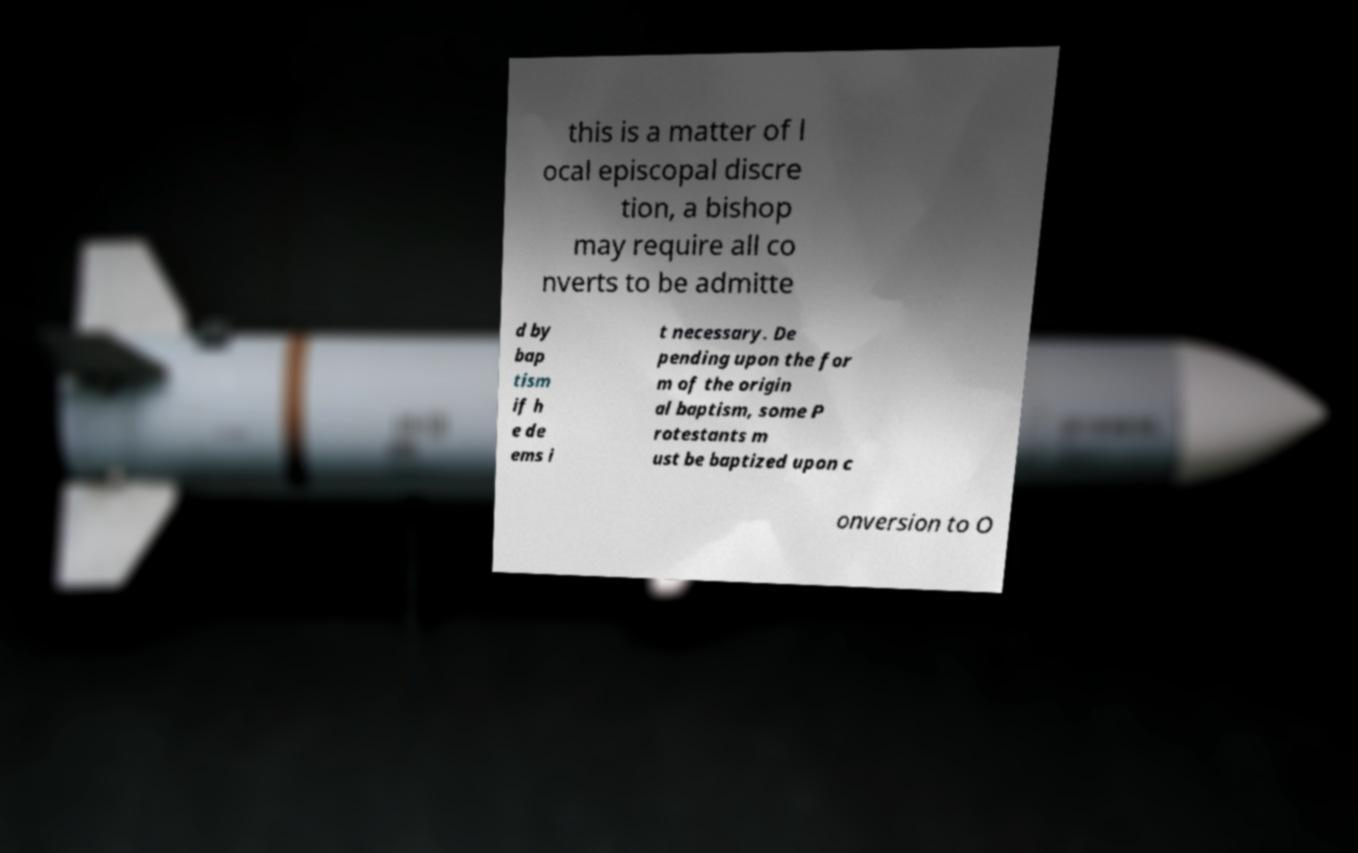Could you assist in decoding the text presented in this image and type it out clearly? this is a matter of l ocal episcopal discre tion, a bishop may require all co nverts to be admitte d by bap tism if h e de ems i t necessary. De pending upon the for m of the origin al baptism, some P rotestants m ust be baptized upon c onversion to O 